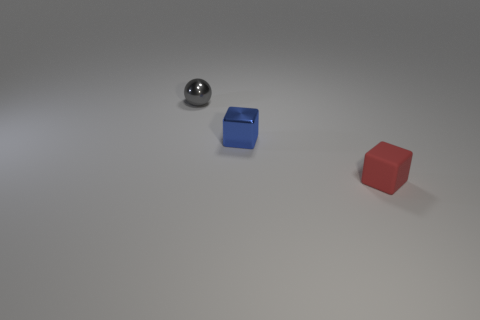Add 3 purple metal cylinders. How many objects exist? 6 Subtract all spheres. How many objects are left? 2 Add 1 gray things. How many gray things exist? 2 Subtract 0 blue spheres. How many objects are left? 3 Subtract all purple cylinders. Subtract all matte blocks. How many objects are left? 2 Add 3 small blue blocks. How many small blue blocks are left? 4 